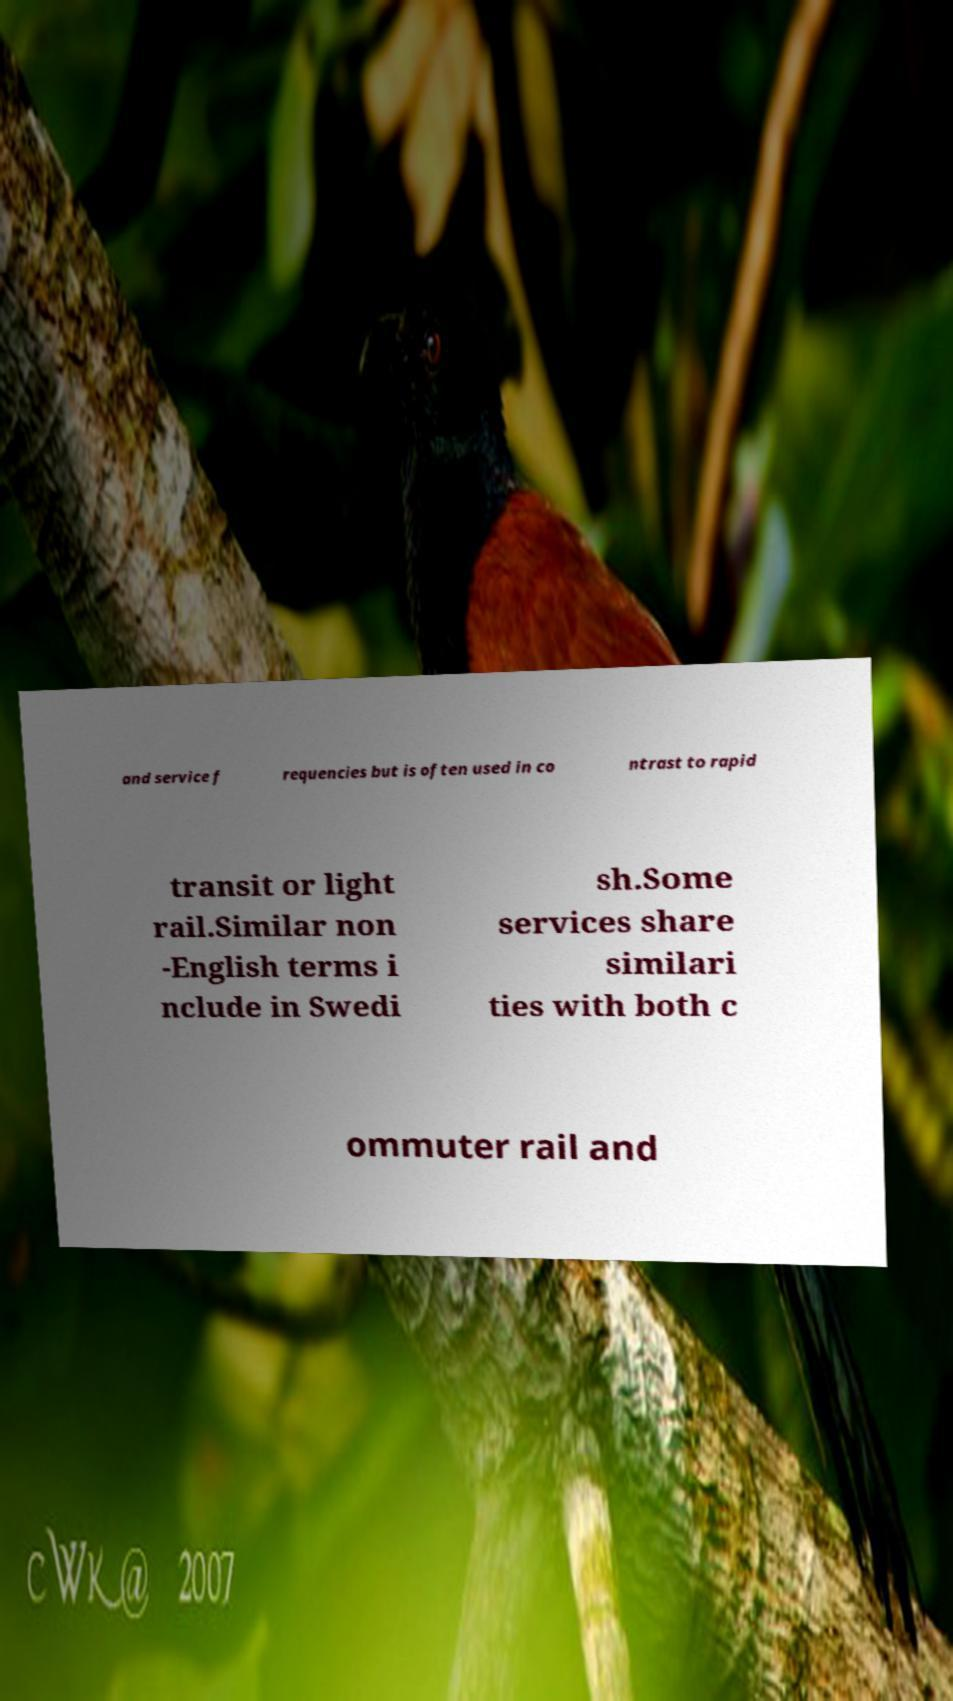Can you read and provide the text displayed in the image?This photo seems to have some interesting text. Can you extract and type it out for me? and service f requencies but is often used in co ntrast to rapid transit or light rail.Similar non -English terms i nclude in Swedi sh.Some services share similari ties with both c ommuter rail and 